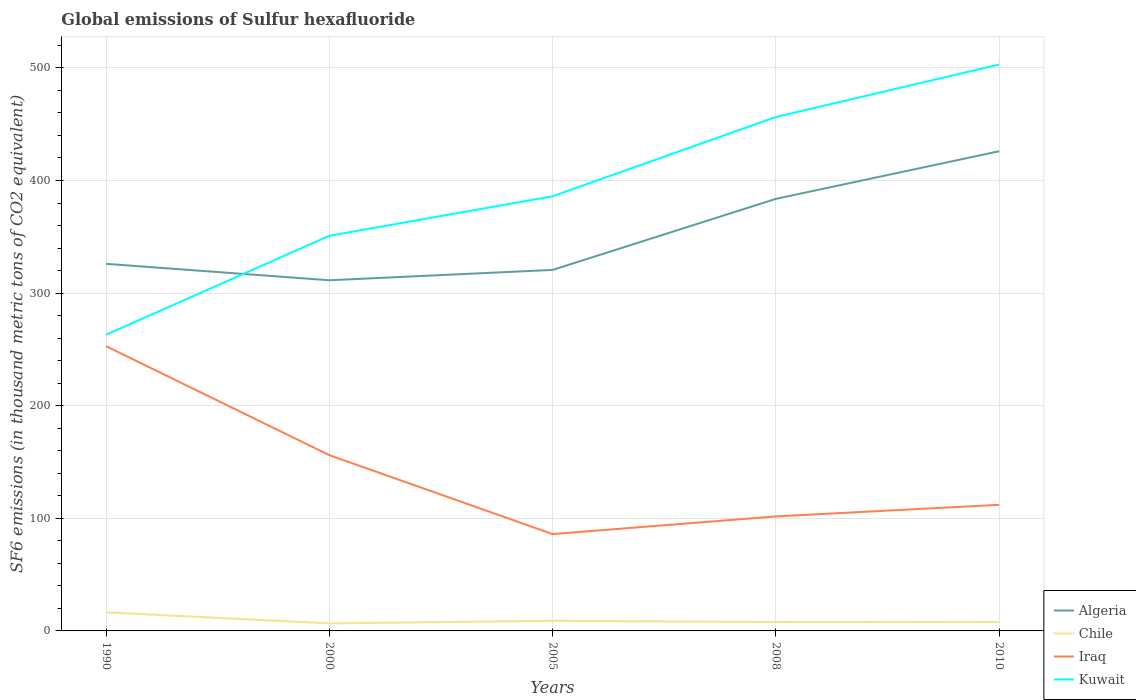Does the line corresponding to Chile intersect with the line corresponding to Algeria?
Provide a short and direct response. No. Is the number of lines equal to the number of legend labels?
Make the answer very short. Yes. Across all years, what is the maximum global emissions of Sulfur hexafluoride in Chile?
Make the answer very short. 6.7. What is the total global emissions of Sulfur hexafluoride in Kuwait in the graph?
Your answer should be compact. -87.9. What is the difference between the highest and the second highest global emissions of Sulfur hexafluoride in Algeria?
Give a very brief answer. 114.6. What is the difference between the highest and the lowest global emissions of Sulfur hexafluoride in Iraq?
Your response must be concise. 2. Is the global emissions of Sulfur hexafluoride in Chile strictly greater than the global emissions of Sulfur hexafluoride in Kuwait over the years?
Provide a short and direct response. Yes. Are the values on the major ticks of Y-axis written in scientific E-notation?
Ensure brevity in your answer.  No. Does the graph contain any zero values?
Your answer should be very brief. No. Does the graph contain grids?
Keep it short and to the point. Yes. Where does the legend appear in the graph?
Make the answer very short. Bottom right. What is the title of the graph?
Offer a terse response. Global emissions of Sulfur hexafluoride. Does "Colombia" appear as one of the legend labels in the graph?
Make the answer very short. No. What is the label or title of the X-axis?
Your answer should be compact. Years. What is the label or title of the Y-axis?
Make the answer very short. SF6 emissions (in thousand metric tons of CO2 equivalent). What is the SF6 emissions (in thousand metric tons of CO2 equivalent) of Algeria in 1990?
Your answer should be very brief. 326. What is the SF6 emissions (in thousand metric tons of CO2 equivalent) of Chile in 1990?
Your answer should be very brief. 16.5. What is the SF6 emissions (in thousand metric tons of CO2 equivalent) of Iraq in 1990?
Give a very brief answer. 252.9. What is the SF6 emissions (in thousand metric tons of CO2 equivalent) of Kuwait in 1990?
Offer a terse response. 263. What is the SF6 emissions (in thousand metric tons of CO2 equivalent) of Algeria in 2000?
Provide a short and direct response. 311.4. What is the SF6 emissions (in thousand metric tons of CO2 equivalent) of Iraq in 2000?
Your response must be concise. 156.1. What is the SF6 emissions (in thousand metric tons of CO2 equivalent) of Kuwait in 2000?
Give a very brief answer. 350.9. What is the SF6 emissions (in thousand metric tons of CO2 equivalent) in Algeria in 2005?
Ensure brevity in your answer.  320.6. What is the SF6 emissions (in thousand metric tons of CO2 equivalent) in Kuwait in 2005?
Provide a succinct answer. 386. What is the SF6 emissions (in thousand metric tons of CO2 equivalent) in Algeria in 2008?
Offer a terse response. 383.7. What is the SF6 emissions (in thousand metric tons of CO2 equivalent) of Iraq in 2008?
Ensure brevity in your answer.  101.7. What is the SF6 emissions (in thousand metric tons of CO2 equivalent) of Kuwait in 2008?
Keep it short and to the point. 456.4. What is the SF6 emissions (in thousand metric tons of CO2 equivalent) in Algeria in 2010?
Offer a very short reply. 426. What is the SF6 emissions (in thousand metric tons of CO2 equivalent) in Chile in 2010?
Your response must be concise. 8. What is the SF6 emissions (in thousand metric tons of CO2 equivalent) of Iraq in 2010?
Make the answer very short. 112. What is the SF6 emissions (in thousand metric tons of CO2 equivalent) of Kuwait in 2010?
Ensure brevity in your answer.  503. Across all years, what is the maximum SF6 emissions (in thousand metric tons of CO2 equivalent) in Algeria?
Provide a succinct answer. 426. Across all years, what is the maximum SF6 emissions (in thousand metric tons of CO2 equivalent) in Iraq?
Give a very brief answer. 252.9. Across all years, what is the maximum SF6 emissions (in thousand metric tons of CO2 equivalent) in Kuwait?
Provide a short and direct response. 503. Across all years, what is the minimum SF6 emissions (in thousand metric tons of CO2 equivalent) of Algeria?
Give a very brief answer. 311.4. Across all years, what is the minimum SF6 emissions (in thousand metric tons of CO2 equivalent) in Chile?
Keep it short and to the point. 6.7. Across all years, what is the minimum SF6 emissions (in thousand metric tons of CO2 equivalent) in Kuwait?
Give a very brief answer. 263. What is the total SF6 emissions (in thousand metric tons of CO2 equivalent) in Algeria in the graph?
Offer a terse response. 1767.7. What is the total SF6 emissions (in thousand metric tons of CO2 equivalent) in Chile in the graph?
Offer a terse response. 48.1. What is the total SF6 emissions (in thousand metric tons of CO2 equivalent) in Iraq in the graph?
Offer a terse response. 708.7. What is the total SF6 emissions (in thousand metric tons of CO2 equivalent) of Kuwait in the graph?
Offer a terse response. 1959.3. What is the difference between the SF6 emissions (in thousand metric tons of CO2 equivalent) of Algeria in 1990 and that in 2000?
Keep it short and to the point. 14.6. What is the difference between the SF6 emissions (in thousand metric tons of CO2 equivalent) in Chile in 1990 and that in 2000?
Provide a succinct answer. 9.8. What is the difference between the SF6 emissions (in thousand metric tons of CO2 equivalent) of Iraq in 1990 and that in 2000?
Offer a very short reply. 96.8. What is the difference between the SF6 emissions (in thousand metric tons of CO2 equivalent) in Kuwait in 1990 and that in 2000?
Your response must be concise. -87.9. What is the difference between the SF6 emissions (in thousand metric tons of CO2 equivalent) of Chile in 1990 and that in 2005?
Your answer should be compact. 7.5. What is the difference between the SF6 emissions (in thousand metric tons of CO2 equivalent) of Iraq in 1990 and that in 2005?
Provide a short and direct response. 166.9. What is the difference between the SF6 emissions (in thousand metric tons of CO2 equivalent) of Kuwait in 1990 and that in 2005?
Offer a very short reply. -123. What is the difference between the SF6 emissions (in thousand metric tons of CO2 equivalent) of Algeria in 1990 and that in 2008?
Keep it short and to the point. -57.7. What is the difference between the SF6 emissions (in thousand metric tons of CO2 equivalent) of Iraq in 1990 and that in 2008?
Provide a short and direct response. 151.2. What is the difference between the SF6 emissions (in thousand metric tons of CO2 equivalent) in Kuwait in 1990 and that in 2008?
Give a very brief answer. -193.4. What is the difference between the SF6 emissions (in thousand metric tons of CO2 equivalent) in Algeria in 1990 and that in 2010?
Ensure brevity in your answer.  -100. What is the difference between the SF6 emissions (in thousand metric tons of CO2 equivalent) of Iraq in 1990 and that in 2010?
Your response must be concise. 140.9. What is the difference between the SF6 emissions (in thousand metric tons of CO2 equivalent) in Kuwait in 1990 and that in 2010?
Ensure brevity in your answer.  -240. What is the difference between the SF6 emissions (in thousand metric tons of CO2 equivalent) of Algeria in 2000 and that in 2005?
Offer a terse response. -9.2. What is the difference between the SF6 emissions (in thousand metric tons of CO2 equivalent) in Chile in 2000 and that in 2005?
Ensure brevity in your answer.  -2.3. What is the difference between the SF6 emissions (in thousand metric tons of CO2 equivalent) in Iraq in 2000 and that in 2005?
Offer a terse response. 70.1. What is the difference between the SF6 emissions (in thousand metric tons of CO2 equivalent) of Kuwait in 2000 and that in 2005?
Offer a terse response. -35.1. What is the difference between the SF6 emissions (in thousand metric tons of CO2 equivalent) of Algeria in 2000 and that in 2008?
Offer a terse response. -72.3. What is the difference between the SF6 emissions (in thousand metric tons of CO2 equivalent) in Chile in 2000 and that in 2008?
Make the answer very short. -1.2. What is the difference between the SF6 emissions (in thousand metric tons of CO2 equivalent) of Iraq in 2000 and that in 2008?
Keep it short and to the point. 54.4. What is the difference between the SF6 emissions (in thousand metric tons of CO2 equivalent) in Kuwait in 2000 and that in 2008?
Give a very brief answer. -105.5. What is the difference between the SF6 emissions (in thousand metric tons of CO2 equivalent) of Algeria in 2000 and that in 2010?
Offer a terse response. -114.6. What is the difference between the SF6 emissions (in thousand metric tons of CO2 equivalent) of Iraq in 2000 and that in 2010?
Offer a terse response. 44.1. What is the difference between the SF6 emissions (in thousand metric tons of CO2 equivalent) of Kuwait in 2000 and that in 2010?
Provide a succinct answer. -152.1. What is the difference between the SF6 emissions (in thousand metric tons of CO2 equivalent) in Algeria in 2005 and that in 2008?
Offer a terse response. -63.1. What is the difference between the SF6 emissions (in thousand metric tons of CO2 equivalent) in Chile in 2005 and that in 2008?
Give a very brief answer. 1.1. What is the difference between the SF6 emissions (in thousand metric tons of CO2 equivalent) of Iraq in 2005 and that in 2008?
Offer a terse response. -15.7. What is the difference between the SF6 emissions (in thousand metric tons of CO2 equivalent) in Kuwait in 2005 and that in 2008?
Provide a succinct answer. -70.4. What is the difference between the SF6 emissions (in thousand metric tons of CO2 equivalent) of Algeria in 2005 and that in 2010?
Give a very brief answer. -105.4. What is the difference between the SF6 emissions (in thousand metric tons of CO2 equivalent) in Chile in 2005 and that in 2010?
Offer a terse response. 1. What is the difference between the SF6 emissions (in thousand metric tons of CO2 equivalent) in Kuwait in 2005 and that in 2010?
Provide a short and direct response. -117. What is the difference between the SF6 emissions (in thousand metric tons of CO2 equivalent) in Algeria in 2008 and that in 2010?
Give a very brief answer. -42.3. What is the difference between the SF6 emissions (in thousand metric tons of CO2 equivalent) in Chile in 2008 and that in 2010?
Your answer should be very brief. -0.1. What is the difference between the SF6 emissions (in thousand metric tons of CO2 equivalent) in Iraq in 2008 and that in 2010?
Keep it short and to the point. -10.3. What is the difference between the SF6 emissions (in thousand metric tons of CO2 equivalent) of Kuwait in 2008 and that in 2010?
Ensure brevity in your answer.  -46.6. What is the difference between the SF6 emissions (in thousand metric tons of CO2 equivalent) in Algeria in 1990 and the SF6 emissions (in thousand metric tons of CO2 equivalent) in Chile in 2000?
Your answer should be compact. 319.3. What is the difference between the SF6 emissions (in thousand metric tons of CO2 equivalent) in Algeria in 1990 and the SF6 emissions (in thousand metric tons of CO2 equivalent) in Iraq in 2000?
Your answer should be compact. 169.9. What is the difference between the SF6 emissions (in thousand metric tons of CO2 equivalent) in Algeria in 1990 and the SF6 emissions (in thousand metric tons of CO2 equivalent) in Kuwait in 2000?
Keep it short and to the point. -24.9. What is the difference between the SF6 emissions (in thousand metric tons of CO2 equivalent) of Chile in 1990 and the SF6 emissions (in thousand metric tons of CO2 equivalent) of Iraq in 2000?
Ensure brevity in your answer.  -139.6. What is the difference between the SF6 emissions (in thousand metric tons of CO2 equivalent) in Chile in 1990 and the SF6 emissions (in thousand metric tons of CO2 equivalent) in Kuwait in 2000?
Offer a terse response. -334.4. What is the difference between the SF6 emissions (in thousand metric tons of CO2 equivalent) in Iraq in 1990 and the SF6 emissions (in thousand metric tons of CO2 equivalent) in Kuwait in 2000?
Your answer should be compact. -98. What is the difference between the SF6 emissions (in thousand metric tons of CO2 equivalent) of Algeria in 1990 and the SF6 emissions (in thousand metric tons of CO2 equivalent) of Chile in 2005?
Offer a terse response. 317. What is the difference between the SF6 emissions (in thousand metric tons of CO2 equivalent) of Algeria in 1990 and the SF6 emissions (in thousand metric tons of CO2 equivalent) of Iraq in 2005?
Ensure brevity in your answer.  240. What is the difference between the SF6 emissions (in thousand metric tons of CO2 equivalent) of Algeria in 1990 and the SF6 emissions (in thousand metric tons of CO2 equivalent) of Kuwait in 2005?
Your response must be concise. -60. What is the difference between the SF6 emissions (in thousand metric tons of CO2 equivalent) in Chile in 1990 and the SF6 emissions (in thousand metric tons of CO2 equivalent) in Iraq in 2005?
Keep it short and to the point. -69.5. What is the difference between the SF6 emissions (in thousand metric tons of CO2 equivalent) in Chile in 1990 and the SF6 emissions (in thousand metric tons of CO2 equivalent) in Kuwait in 2005?
Offer a very short reply. -369.5. What is the difference between the SF6 emissions (in thousand metric tons of CO2 equivalent) of Iraq in 1990 and the SF6 emissions (in thousand metric tons of CO2 equivalent) of Kuwait in 2005?
Keep it short and to the point. -133.1. What is the difference between the SF6 emissions (in thousand metric tons of CO2 equivalent) in Algeria in 1990 and the SF6 emissions (in thousand metric tons of CO2 equivalent) in Chile in 2008?
Provide a short and direct response. 318.1. What is the difference between the SF6 emissions (in thousand metric tons of CO2 equivalent) in Algeria in 1990 and the SF6 emissions (in thousand metric tons of CO2 equivalent) in Iraq in 2008?
Ensure brevity in your answer.  224.3. What is the difference between the SF6 emissions (in thousand metric tons of CO2 equivalent) in Algeria in 1990 and the SF6 emissions (in thousand metric tons of CO2 equivalent) in Kuwait in 2008?
Ensure brevity in your answer.  -130.4. What is the difference between the SF6 emissions (in thousand metric tons of CO2 equivalent) in Chile in 1990 and the SF6 emissions (in thousand metric tons of CO2 equivalent) in Iraq in 2008?
Your response must be concise. -85.2. What is the difference between the SF6 emissions (in thousand metric tons of CO2 equivalent) of Chile in 1990 and the SF6 emissions (in thousand metric tons of CO2 equivalent) of Kuwait in 2008?
Keep it short and to the point. -439.9. What is the difference between the SF6 emissions (in thousand metric tons of CO2 equivalent) in Iraq in 1990 and the SF6 emissions (in thousand metric tons of CO2 equivalent) in Kuwait in 2008?
Give a very brief answer. -203.5. What is the difference between the SF6 emissions (in thousand metric tons of CO2 equivalent) of Algeria in 1990 and the SF6 emissions (in thousand metric tons of CO2 equivalent) of Chile in 2010?
Your answer should be very brief. 318. What is the difference between the SF6 emissions (in thousand metric tons of CO2 equivalent) in Algeria in 1990 and the SF6 emissions (in thousand metric tons of CO2 equivalent) in Iraq in 2010?
Provide a short and direct response. 214. What is the difference between the SF6 emissions (in thousand metric tons of CO2 equivalent) of Algeria in 1990 and the SF6 emissions (in thousand metric tons of CO2 equivalent) of Kuwait in 2010?
Provide a short and direct response. -177. What is the difference between the SF6 emissions (in thousand metric tons of CO2 equivalent) of Chile in 1990 and the SF6 emissions (in thousand metric tons of CO2 equivalent) of Iraq in 2010?
Your answer should be compact. -95.5. What is the difference between the SF6 emissions (in thousand metric tons of CO2 equivalent) in Chile in 1990 and the SF6 emissions (in thousand metric tons of CO2 equivalent) in Kuwait in 2010?
Provide a short and direct response. -486.5. What is the difference between the SF6 emissions (in thousand metric tons of CO2 equivalent) in Iraq in 1990 and the SF6 emissions (in thousand metric tons of CO2 equivalent) in Kuwait in 2010?
Your answer should be very brief. -250.1. What is the difference between the SF6 emissions (in thousand metric tons of CO2 equivalent) in Algeria in 2000 and the SF6 emissions (in thousand metric tons of CO2 equivalent) in Chile in 2005?
Offer a very short reply. 302.4. What is the difference between the SF6 emissions (in thousand metric tons of CO2 equivalent) in Algeria in 2000 and the SF6 emissions (in thousand metric tons of CO2 equivalent) in Iraq in 2005?
Ensure brevity in your answer.  225.4. What is the difference between the SF6 emissions (in thousand metric tons of CO2 equivalent) in Algeria in 2000 and the SF6 emissions (in thousand metric tons of CO2 equivalent) in Kuwait in 2005?
Your response must be concise. -74.6. What is the difference between the SF6 emissions (in thousand metric tons of CO2 equivalent) of Chile in 2000 and the SF6 emissions (in thousand metric tons of CO2 equivalent) of Iraq in 2005?
Make the answer very short. -79.3. What is the difference between the SF6 emissions (in thousand metric tons of CO2 equivalent) of Chile in 2000 and the SF6 emissions (in thousand metric tons of CO2 equivalent) of Kuwait in 2005?
Ensure brevity in your answer.  -379.3. What is the difference between the SF6 emissions (in thousand metric tons of CO2 equivalent) of Iraq in 2000 and the SF6 emissions (in thousand metric tons of CO2 equivalent) of Kuwait in 2005?
Offer a very short reply. -229.9. What is the difference between the SF6 emissions (in thousand metric tons of CO2 equivalent) of Algeria in 2000 and the SF6 emissions (in thousand metric tons of CO2 equivalent) of Chile in 2008?
Provide a succinct answer. 303.5. What is the difference between the SF6 emissions (in thousand metric tons of CO2 equivalent) of Algeria in 2000 and the SF6 emissions (in thousand metric tons of CO2 equivalent) of Iraq in 2008?
Provide a short and direct response. 209.7. What is the difference between the SF6 emissions (in thousand metric tons of CO2 equivalent) in Algeria in 2000 and the SF6 emissions (in thousand metric tons of CO2 equivalent) in Kuwait in 2008?
Keep it short and to the point. -145. What is the difference between the SF6 emissions (in thousand metric tons of CO2 equivalent) of Chile in 2000 and the SF6 emissions (in thousand metric tons of CO2 equivalent) of Iraq in 2008?
Make the answer very short. -95. What is the difference between the SF6 emissions (in thousand metric tons of CO2 equivalent) in Chile in 2000 and the SF6 emissions (in thousand metric tons of CO2 equivalent) in Kuwait in 2008?
Your answer should be compact. -449.7. What is the difference between the SF6 emissions (in thousand metric tons of CO2 equivalent) in Iraq in 2000 and the SF6 emissions (in thousand metric tons of CO2 equivalent) in Kuwait in 2008?
Offer a terse response. -300.3. What is the difference between the SF6 emissions (in thousand metric tons of CO2 equivalent) in Algeria in 2000 and the SF6 emissions (in thousand metric tons of CO2 equivalent) in Chile in 2010?
Give a very brief answer. 303.4. What is the difference between the SF6 emissions (in thousand metric tons of CO2 equivalent) in Algeria in 2000 and the SF6 emissions (in thousand metric tons of CO2 equivalent) in Iraq in 2010?
Your response must be concise. 199.4. What is the difference between the SF6 emissions (in thousand metric tons of CO2 equivalent) of Algeria in 2000 and the SF6 emissions (in thousand metric tons of CO2 equivalent) of Kuwait in 2010?
Offer a very short reply. -191.6. What is the difference between the SF6 emissions (in thousand metric tons of CO2 equivalent) in Chile in 2000 and the SF6 emissions (in thousand metric tons of CO2 equivalent) in Iraq in 2010?
Your answer should be compact. -105.3. What is the difference between the SF6 emissions (in thousand metric tons of CO2 equivalent) of Chile in 2000 and the SF6 emissions (in thousand metric tons of CO2 equivalent) of Kuwait in 2010?
Your answer should be very brief. -496.3. What is the difference between the SF6 emissions (in thousand metric tons of CO2 equivalent) of Iraq in 2000 and the SF6 emissions (in thousand metric tons of CO2 equivalent) of Kuwait in 2010?
Ensure brevity in your answer.  -346.9. What is the difference between the SF6 emissions (in thousand metric tons of CO2 equivalent) of Algeria in 2005 and the SF6 emissions (in thousand metric tons of CO2 equivalent) of Chile in 2008?
Provide a succinct answer. 312.7. What is the difference between the SF6 emissions (in thousand metric tons of CO2 equivalent) of Algeria in 2005 and the SF6 emissions (in thousand metric tons of CO2 equivalent) of Iraq in 2008?
Your answer should be compact. 218.9. What is the difference between the SF6 emissions (in thousand metric tons of CO2 equivalent) in Algeria in 2005 and the SF6 emissions (in thousand metric tons of CO2 equivalent) in Kuwait in 2008?
Your response must be concise. -135.8. What is the difference between the SF6 emissions (in thousand metric tons of CO2 equivalent) in Chile in 2005 and the SF6 emissions (in thousand metric tons of CO2 equivalent) in Iraq in 2008?
Make the answer very short. -92.7. What is the difference between the SF6 emissions (in thousand metric tons of CO2 equivalent) in Chile in 2005 and the SF6 emissions (in thousand metric tons of CO2 equivalent) in Kuwait in 2008?
Give a very brief answer. -447.4. What is the difference between the SF6 emissions (in thousand metric tons of CO2 equivalent) of Iraq in 2005 and the SF6 emissions (in thousand metric tons of CO2 equivalent) of Kuwait in 2008?
Ensure brevity in your answer.  -370.4. What is the difference between the SF6 emissions (in thousand metric tons of CO2 equivalent) of Algeria in 2005 and the SF6 emissions (in thousand metric tons of CO2 equivalent) of Chile in 2010?
Ensure brevity in your answer.  312.6. What is the difference between the SF6 emissions (in thousand metric tons of CO2 equivalent) in Algeria in 2005 and the SF6 emissions (in thousand metric tons of CO2 equivalent) in Iraq in 2010?
Your answer should be compact. 208.6. What is the difference between the SF6 emissions (in thousand metric tons of CO2 equivalent) in Algeria in 2005 and the SF6 emissions (in thousand metric tons of CO2 equivalent) in Kuwait in 2010?
Make the answer very short. -182.4. What is the difference between the SF6 emissions (in thousand metric tons of CO2 equivalent) in Chile in 2005 and the SF6 emissions (in thousand metric tons of CO2 equivalent) in Iraq in 2010?
Provide a short and direct response. -103. What is the difference between the SF6 emissions (in thousand metric tons of CO2 equivalent) in Chile in 2005 and the SF6 emissions (in thousand metric tons of CO2 equivalent) in Kuwait in 2010?
Offer a very short reply. -494. What is the difference between the SF6 emissions (in thousand metric tons of CO2 equivalent) of Iraq in 2005 and the SF6 emissions (in thousand metric tons of CO2 equivalent) of Kuwait in 2010?
Offer a very short reply. -417. What is the difference between the SF6 emissions (in thousand metric tons of CO2 equivalent) in Algeria in 2008 and the SF6 emissions (in thousand metric tons of CO2 equivalent) in Chile in 2010?
Your answer should be very brief. 375.7. What is the difference between the SF6 emissions (in thousand metric tons of CO2 equivalent) in Algeria in 2008 and the SF6 emissions (in thousand metric tons of CO2 equivalent) in Iraq in 2010?
Make the answer very short. 271.7. What is the difference between the SF6 emissions (in thousand metric tons of CO2 equivalent) in Algeria in 2008 and the SF6 emissions (in thousand metric tons of CO2 equivalent) in Kuwait in 2010?
Offer a very short reply. -119.3. What is the difference between the SF6 emissions (in thousand metric tons of CO2 equivalent) in Chile in 2008 and the SF6 emissions (in thousand metric tons of CO2 equivalent) in Iraq in 2010?
Your answer should be very brief. -104.1. What is the difference between the SF6 emissions (in thousand metric tons of CO2 equivalent) in Chile in 2008 and the SF6 emissions (in thousand metric tons of CO2 equivalent) in Kuwait in 2010?
Keep it short and to the point. -495.1. What is the difference between the SF6 emissions (in thousand metric tons of CO2 equivalent) in Iraq in 2008 and the SF6 emissions (in thousand metric tons of CO2 equivalent) in Kuwait in 2010?
Offer a terse response. -401.3. What is the average SF6 emissions (in thousand metric tons of CO2 equivalent) of Algeria per year?
Ensure brevity in your answer.  353.54. What is the average SF6 emissions (in thousand metric tons of CO2 equivalent) of Chile per year?
Your response must be concise. 9.62. What is the average SF6 emissions (in thousand metric tons of CO2 equivalent) of Iraq per year?
Your answer should be compact. 141.74. What is the average SF6 emissions (in thousand metric tons of CO2 equivalent) in Kuwait per year?
Make the answer very short. 391.86. In the year 1990, what is the difference between the SF6 emissions (in thousand metric tons of CO2 equivalent) of Algeria and SF6 emissions (in thousand metric tons of CO2 equivalent) of Chile?
Your answer should be very brief. 309.5. In the year 1990, what is the difference between the SF6 emissions (in thousand metric tons of CO2 equivalent) in Algeria and SF6 emissions (in thousand metric tons of CO2 equivalent) in Iraq?
Your answer should be compact. 73.1. In the year 1990, what is the difference between the SF6 emissions (in thousand metric tons of CO2 equivalent) in Chile and SF6 emissions (in thousand metric tons of CO2 equivalent) in Iraq?
Make the answer very short. -236.4. In the year 1990, what is the difference between the SF6 emissions (in thousand metric tons of CO2 equivalent) of Chile and SF6 emissions (in thousand metric tons of CO2 equivalent) of Kuwait?
Ensure brevity in your answer.  -246.5. In the year 2000, what is the difference between the SF6 emissions (in thousand metric tons of CO2 equivalent) of Algeria and SF6 emissions (in thousand metric tons of CO2 equivalent) of Chile?
Your answer should be very brief. 304.7. In the year 2000, what is the difference between the SF6 emissions (in thousand metric tons of CO2 equivalent) in Algeria and SF6 emissions (in thousand metric tons of CO2 equivalent) in Iraq?
Your answer should be compact. 155.3. In the year 2000, what is the difference between the SF6 emissions (in thousand metric tons of CO2 equivalent) of Algeria and SF6 emissions (in thousand metric tons of CO2 equivalent) of Kuwait?
Your answer should be very brief. -39.5. In the year 2000, what is the difference between the SF6 emissions (in thousand metric tons of CO2 equivalent) in Chile and SF6 emissions (in thousand metric tons of CO2 equivalent) in Iraq?
Your answer should be compact. -149.4. In the year 2000, what is the difference between the SF6 emissions (in thousand metric tons of CO2 equivalent) in Chile and SF6 emissions (in thousand metric tons of CO2 equivalent) in Kuwait?
Provide a short and direct response. -344.2. In the year 2000, what is the difference between the SF6 emissions (in thousand metric tons of CO2 equivalent) in Iraq and SF6 emissions (in thousand metric tons of CO2 equivalent) in Kuwait?
Offer a terse response. -194.8. In the year 2005, what is the difference between the SF6 emissions (in thousand metric tons of CO2 equivalent) in Algeria and SF6 emissions (in thousand metric tons of CO2 equivalent) in Chile?
Offer a very short reply. 311.6. In the year 2005, what is the difference between the SF6 emissions (in thousand metric tons of CO2 equivalent) of Algeria and SF6 emissions (in thousand metric tons of CO2 equivalent) of Iraq?
Keep it short and to the point. 234.6. In the year 2005, what is the difference between the SF6 emissions (in thousand metric tons of CO2 equivalent) of Algeria and SF6 emissions (in thousand metric tons of CO2 equivalent) of Kuwait?
Offer a terse response. -65.4. In the year 2005, what is the difference between the SF6 emissions (in thousand metric tons of CO2 equivalent) of Chile and SF6 emissions (in thousand metric tons of CO2 equivalent) of Iraq?
Offer a very short reply. -77. In the year 2005, what is the difference between the SF6 emissions (in thousand metric tons of CO2 equivalent) of Chile and SF6 emissions (in thousand metric tons of CO2 equivalent) of Kuwait?
Keep it short and to the point. -377. In the year 2005, what is the difference between the SF6 emissions (in thousand metric tons of CO2 equivalent) in Iraq and SF6 emissions (in thousand metric tons of CO2 equivalent) in Kuwait?
Make the answer very short. -300. In the year 2008, what is the difference between the SF6 emissions (in thousand metric tons of CO2 equivalent) in Algeria and SF6 emissions (in thousand metric tons of CO2 equivalent) in Chile?
Provide a succinct answer. 375.8. In the year 2008, what is the difference between the SF6 emissions (in thousand metric tons of CO2 equivalent) of Algeria and SF6 emissions (in thousand metric tons of CO2 equivalent) of Iraq?
Make the answer very short. 282. In the year 2008, what is the difference between the SF6 emissions (in thousand metric tons of CO2 equivalent) of Algeria and SF6 emissions (in thousand metric tons of CO2 equivalent) of Kuwait?
Provide a succinct answer. -72.7. In the year 2008, what is the difference between the SF6 emissions (in thousand metric tons of CO2 equivalent) of Chile and SF6 emissions (in thousand metric tons of CO2 equivalent) of Iraq?
Make the answer very short. -93.8. In the year 2008, what is the difference between the SF6 emissions (in thousand metric tons of CO2 equivalent) in Chile and SF6 emissions (in thousand metric tons of CO2 equivalent) in Kuwait?
Give a very brief answer. -448.5. In the year 2008, what is the difference between the SF6 emissions (in thousand metric tons of CO2 equivalent) of Iraq and SF6 emissions (in thousand metric tons of CO2 equivalent) of Kuwait?
Offer a very short reply. -354.7. In the year 2010, what is the difference between the SF6 emissions (in thousand metric tons of CO2 equivalent) in Algeria and SF6 emissions (in thousand metric tons of CO2 equivalent) in Chile?
Keep it short and to the point. 418. In the year 2010, what is the difference between the SF6 emissions (in thousand metric tons of CO2 equivalent) of Algeria and SF6 emissions (in thousand metric tons of CO2 equivalent) of Iraq?
Keep it short and to the point. 314. In the year 2010, what is the difference between the SF6 emissions (in thousand metric tons of CO2 equivalent) in Algeria and SF6 emissions (in thousand metric tons of CO2 equivalent) in Kuwait?
Your answer should be compact. -77. In the year 2010, what is the difference between the SF6 emissions (in thousand metric tons of CO2 equivalent) in Chile and SF6 emissions (in thousand metric tons of CO2 equivalent) in Iraq?
Your response must be concise. -104. In the year 2010, what is the difference between the SF6 emissions (in thousand metric tons of CO2 equivalent) of Chile and SF6 emissions (in thousand metric tons of CO2 equivalent) of Kuwait?
Give a very brief answer. -495. In the year 2010, what is the difference between the SF6 emissions (in thousand metric tons of CO2 equivalent) of Iraq and SF6 emissions (in thousand metric tons of CO2 equivalent) of Kuwait?
Offer a terse response. -391. What is the ratio of the SF6 emissions (in thousand metric tons of CO2 equivalent) of Algeria in 1990 to that in 2000?
Provide a succinct answer. 1.05. What is the ratio of the SF6 emissions (in thousand metric tons of CO2 equivalent) of Chile in 1990 to that in 2000?
Provide a succinct answer. 2.46. What is the ratio of the SF6 emissions (in thousand metric tons of CO2 equivalent) of Iraq in 1990 to that in 2000?
Offer a terse response. 1.62. What is the ratio of the SF6 emissions (in thousand metric tons of CO2 equivalent) in Kuwait in 1990 to that in 2000?
Offer a terse response. 0.75. What is the ratio of the SF6 emissions (in thousand metric tons of CO2 equivalent) in Algeria in 1990 to that in 2005?
Your answer should be compact. 1.02. What is the ratio of the SF6 emissions (in thousand metric tons of CO2 equivalent) of Chile in 1990 to that in 2005?
Offer a very short reply. 1.83. What is the ratio of the SF6 emissions (in thousand metric tons of CO2 equivalent) in Iraq in 1990 to that in 2005?
Offer a terse response. 2.94. What is the ratio of the SF6 emissions (in thousand metric tons of CO2 equivalent) of Kuwait in 1990 to that in 2005?
Your answer should be very brief. 0.68. What is the ratio of the SF6 emissions (in thousand metric tons of CO2 equivalent) of Algeria in 1990 to that in 2008?
Make the answer very short. 0.85. What is the ratio of the SF6 emissions (in thousand metric tons of CO2 equivalent) in Chile in 1990 to that in 2008?
Your answer should be compact. 2.09. What is the ratio of the SF6 emissions (in thousand metric tons of CO2 equivalent) in Iraq in 1990 to that in 2008?
Give a very brief answer. 2.49. What is the ratio of the SF6 emissions (in thousand metric tons of CO2 equivalent) of Kuwait in 1990 to that in 2008?
Offer a very short reply. 0.58. What is the ratio of the SF6 emissions (in thousand metric tons of CO2 equivalent) in Algeria in 1990 to that in 2010?
Offer a terse response. 0.77. What is the ratio of the SF6 emissions (in thousand metric tons of CO2 equivalent) in Chile in 1990 to that in 2010?
Give a very brief answer. 2.06. What is the ratio of the SF6 emissions (in thousand metric tons of CO2 equivalent) in Iraq in 1990 to that in 2010?
Make the answer very short. 2.26. What is the ratio of the SF6 emissions (in thousand metric tons of CO2 equivalent) in Kuwait in 1990 to that in 2010?
Offer a terse response. 0.52. What is the ratio of the SF6 emissions (in thousand metric tons of CO2 equivalent) of Algeria in 2000 to that in 2005?
Your answer should be very brief. 0.97. What is the ratio of the SF6 emissions (in thousand metric tons of CO2 equivalent) of Chile in 2000 to that in 2005?
Keep it short and to the point. 0.74. What is the ratio of the SF6 emissions (in thousand metric tons of CO2 equivalent) in Iraq in 2000 to that in 2005?
Offer a very short reply. 1.82. What is the ratio of the SF6 emissions (in thousand metric tons of CO2 equivalent) of Algeria in 2000 to that in 2008?
Your answer should be very brief. 0.81. What is the ratio of the SF6 emissions (in thousand metric tons of CO2 equivalent) in Chile in 2000 to that in 2008?
Offer a very short reply. 0.85. What is the ratio of the SF6 emissions (in thousand metric tons of CO2 equivalent) in Iraq in 2000 to that in 2008?
Keep it short and to the point. 1.53. What is the ratio of the SF6 emissions (in thousand metric tons of CO2 equivalent) of Kuwait in 2000 to that in 2008?
Your answer should be very brief. 0.77. What is the ratio of the SF6 emissions (in thousand metric tons of CO2 equivalent) in Algeria in 2000 to that in 2010?
Make the answer very short. 0.73. What is the ratio of the SF6 emissions (in thousand metric tons of CO2 equivalent) in Chile in 2000 to that in 2010?
Offer a terse response. 0.84. What is the ratio of the SF6 emissions (in thousand metric tons of CO2 equivalent) of Iraq in 2000 to that in 2010?
Ensure brevity in your answer.  1.39. What is the ratio of the SF6 emissions (in thousand metric tons of CO2 equivalent) in Kuwait in 2000 to that in 2010?
Provide a succinct answer. 0.7. What is the ratio of the SF6 emissions (in thousand metric tons of CO2 equivalent) in Algeria in 2005 to that in 2008?
Ensure brevity in your answer.  0.84. What is the ratio of the SF6 emissions (in thousand metric tons of CO2 equivalent) of Chile in 2005 to that in 2008?
Ensure brevity in your answer.  1.14. What is the ratio of the SF6 emissions (in thousand metric tons of CO2 equivalent) in Iraq in 2005 to that in 2008?
Give a very brief answer. 0.85. What is the ratio of the SF6 emissions (in thousand metric tons of CO2 equivalent) of Kuwait in 2005 to that in 2008?
Keep it short and to the point. 0.85. What is the ratio of the SF6 emissions (in thousand metric tons of CO2 equivalent) of Algeria in 2005 to that in 2010?
Provide a succinct answer. 0.75. What is the ratio of the SF6 emissions (in thousand metric tons of CO2 equivalent) in Iraq in 2005 to that in 2010?
Offer a very short reply. 0.77. What is the ratio of the SF6 emissions (in thousand metric tons of CO2 equivalent) of Kuwait in 2005 to that in 2010?
Give a very brief answer. 0.77. What is the ratio of the SF6 emissions (in thousand metric tons of CO2 equivalent) in Algeria in 2008 to that in 2010?
Ensure brevity in your answer.  0.9. What is the ratio of the SF6 emissions (in thousand metric tons of CO2 equivalent) in Chile in 2008 to that in 2010?
Provide a short and direct response. 0.99. What is the ratio of the SF6 emissions (in thousand metric tons of CO2 equivalent) of Iraq in 2008 to that in 2010?
Your answer should be compact. 0.91. What is the ratio of the SF6 emissions (in thousand metric tons of CO2 equivalent) in Kuwait in 2008 to that in 2010?
Provide a succinct answer. 0.91. What is the difference between the highest and the second highest SF6 emissions (in thousand metric tons of CO2 equivalent) in Algeria?
Make the answer very short. 42.3. What is the difference between the highest and the second highest SF6 emissions (in thousand metric tons of CO2 equivalent) of Chile?
Offer a very short reply. 7.5. What is the difference between the highest and the second highest SF6 emissions (in thousand metric tons of CO2 equivalent) in Iraq?
Provide a short and direct response. 96.8. What is the difference between the highest and the second highest SF6 emissions (in thousand metric tons of CO2 equivalent) of Kuwait?
Offer a very short reply. 46.6. What is the difference between the highest and the lowest SF6 emissions (in thousand metric tons of CO2 equivalent) in Algeria?
Your response must be concise. 114.6. What is the difference between the highest and the lowest SF6 emissions (in thousand metric tons of CO2 equivalent) in Iraq?
Give a very brief answer. 166.9. What is the difference between the highest and the lowest SF6 emissions (in thousand metric tons of CO2 equivalent) in Kuwait?
Provide a short and direct response. 240. 